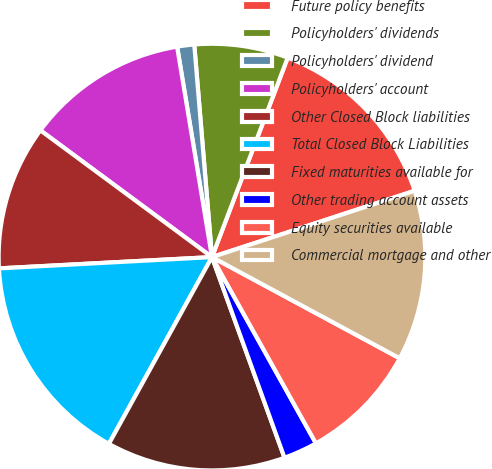Convert chart to OTSL. <chart><loc_0><loc_0><loc_500><loc_500><pie_chart><fcel>Future policy benefits<fcel>Policyholders' dividends<fcel>Policyholders' dividend<fcel>Policyholders' account<fcel>Other Closed Block liabilities<fcel>Total Closed Block Liabilities<fcel>Fixed maturities available for<fcel>Other trading account assets<fcel>Equity securities available<fcel>Commercial mortgage and other<nl><fcel>14.19%<fcel>7.1%<fcel>1.29%<fcel>12.26%<fcel>10.97%<fcel>16.13%<fcel>13.55%<fcel>2.58%<fcel>9.03%<fcel>12.9%<nl></chart> 